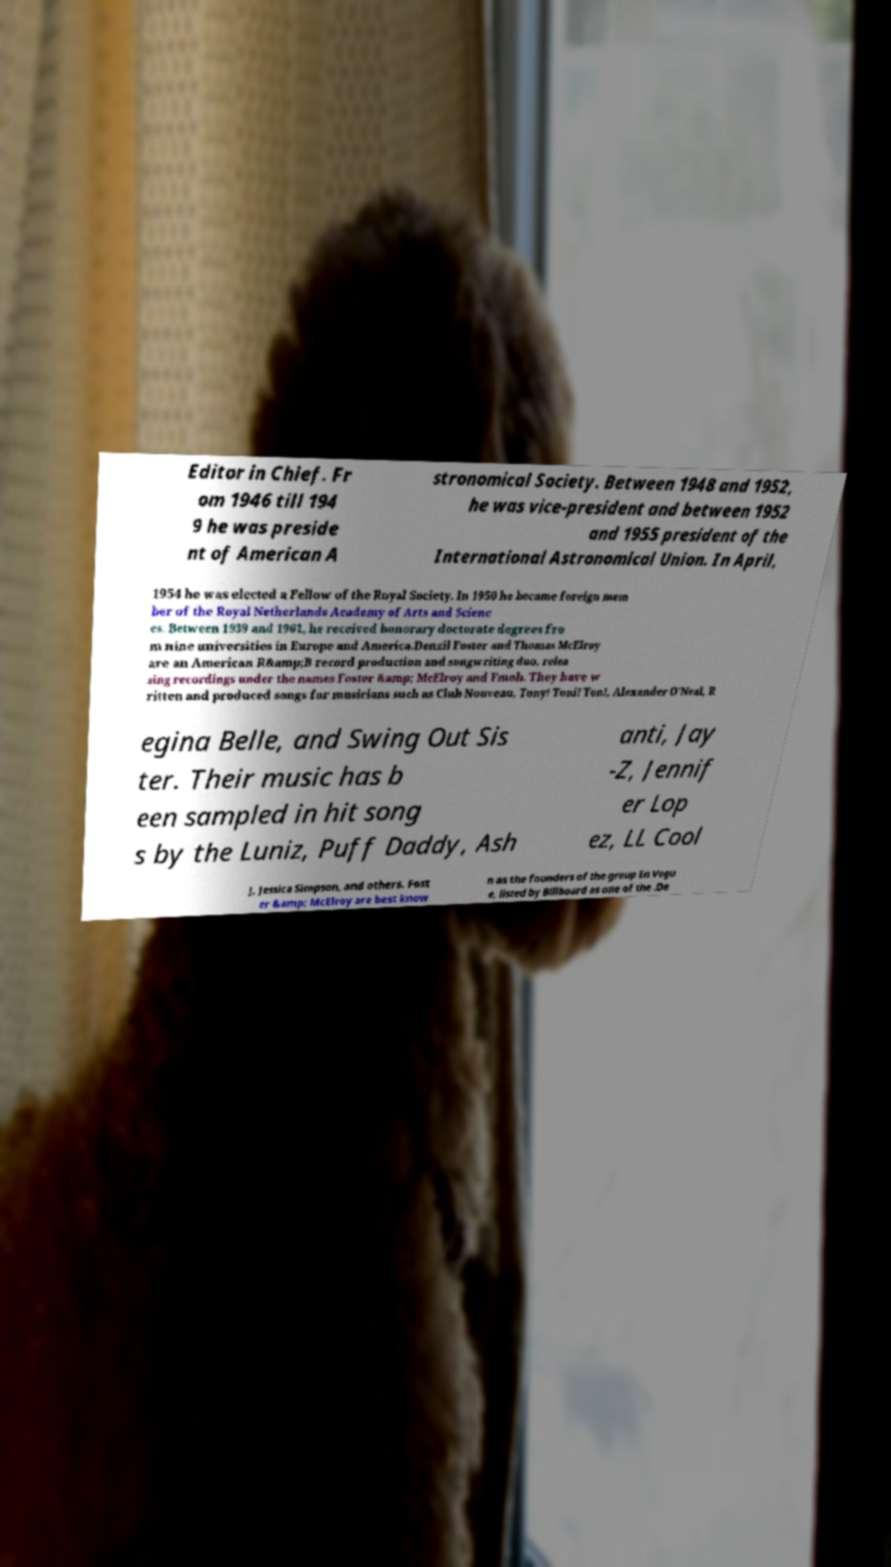Please read and relay the text visible in this image. What does it say? Editor in Chief. Fr om 1946 till 194 9 he was preside nt of American A stronomical Society. Between 1948 and 1952, he was vice-president and between 1952 and 1955 president of the International Astronomical Union. In April, 1954 he was elected a Fellow of the Royal Society. In 1950 he became foreign mem ber of the Royal Netherlands Academy of Arts and Scienc es. Between 1939 and 1961, he received honorary doctorate degrees fro m nine universities in Europe and America.Denzil Foster and Thomas McElroy are an American R&amp;B record production and songwriting duo, relea sing recordings under the names Foster &amp; McElroy and Fmob. They have w ritten and produced songs for musicians such as Club Nouveau, Tony! Toni! Ton!, Alexander O'Neal, R egina Belle, and Swing Out Sis ter. Their music has b een sampled in hit song s by the Luniz, Puff Daddy, Ash anti, Jay -Z, Jennif er Lop ez, LL Cool J, Jessica Simpson, and others. Fost er &amp; McElroy are best know n as the founders of the group En Vogu e, listed by Billboard as one of the .De 